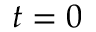<formula> <loc_0><loc_0><loc_500><loc_500>t = 0</formula> 